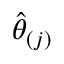<formula> <loc_0><loc_0><loc_500><loc_500>\widehat { \theta } _ { ( j ) }</formula> 